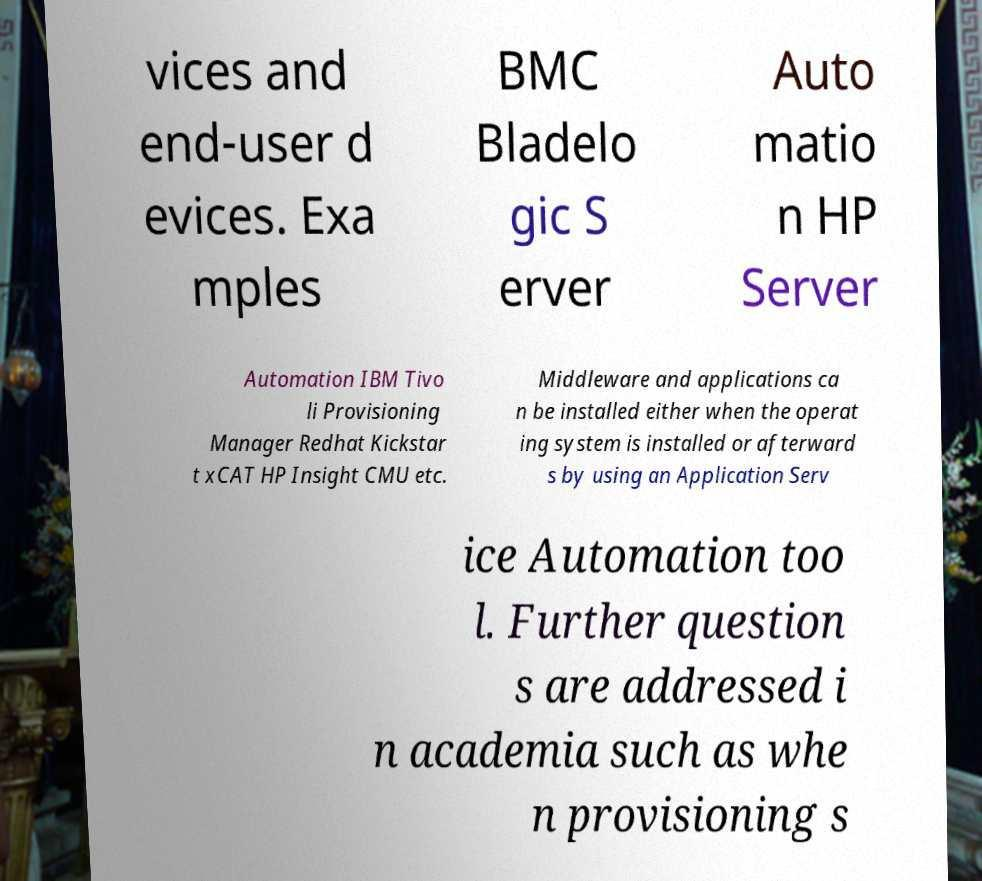Please read and relay the text visible in this image. What does it say? vices and end-user d evices. Exa mples BMC Bladelo gic S erver Auto matio n HP Server Automation IBM Tivo li Provisioning Manager Redhat Kickstar t xCAT HP Insight CMU etc. Middleware and applications ca n be installed either when the operat ing system is installed or afterward s by using an Application Serv ice Automation too l. Further question s are addressed i n academia such as whe n provisioning s 